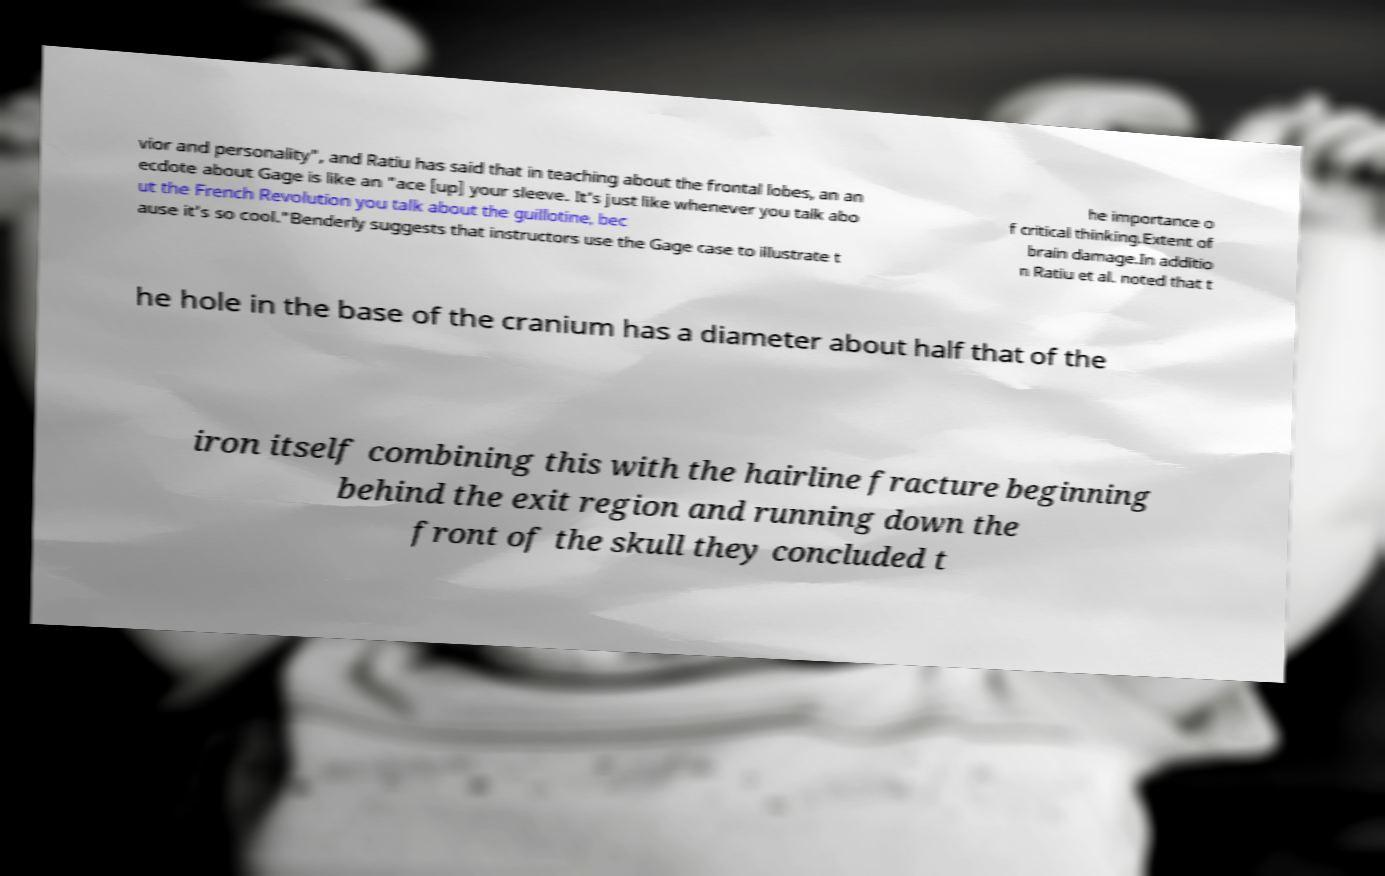Could you assist in decoding the text presented in this image and type it out clearly? vior and personality", and Ratiu has said that in teaching about the frontal lobes, an an ecdote about Gage is like an "ace [up] your sleeve. It's just like whenever you talk abo ut the French Revolution you talk about the guillotine, bec ause it's so cool."Benderly suggests that instructors use the Gage case to illustrate t he importance o f critical thinking.Extent of brain damage.In additio n Ratiu et al. noted that t he hole in the base of the cranium has a diameter about half that of the iron itself combining this with the hairline fracture beginning behind the exit region and running down the front of the skull they concluded t 